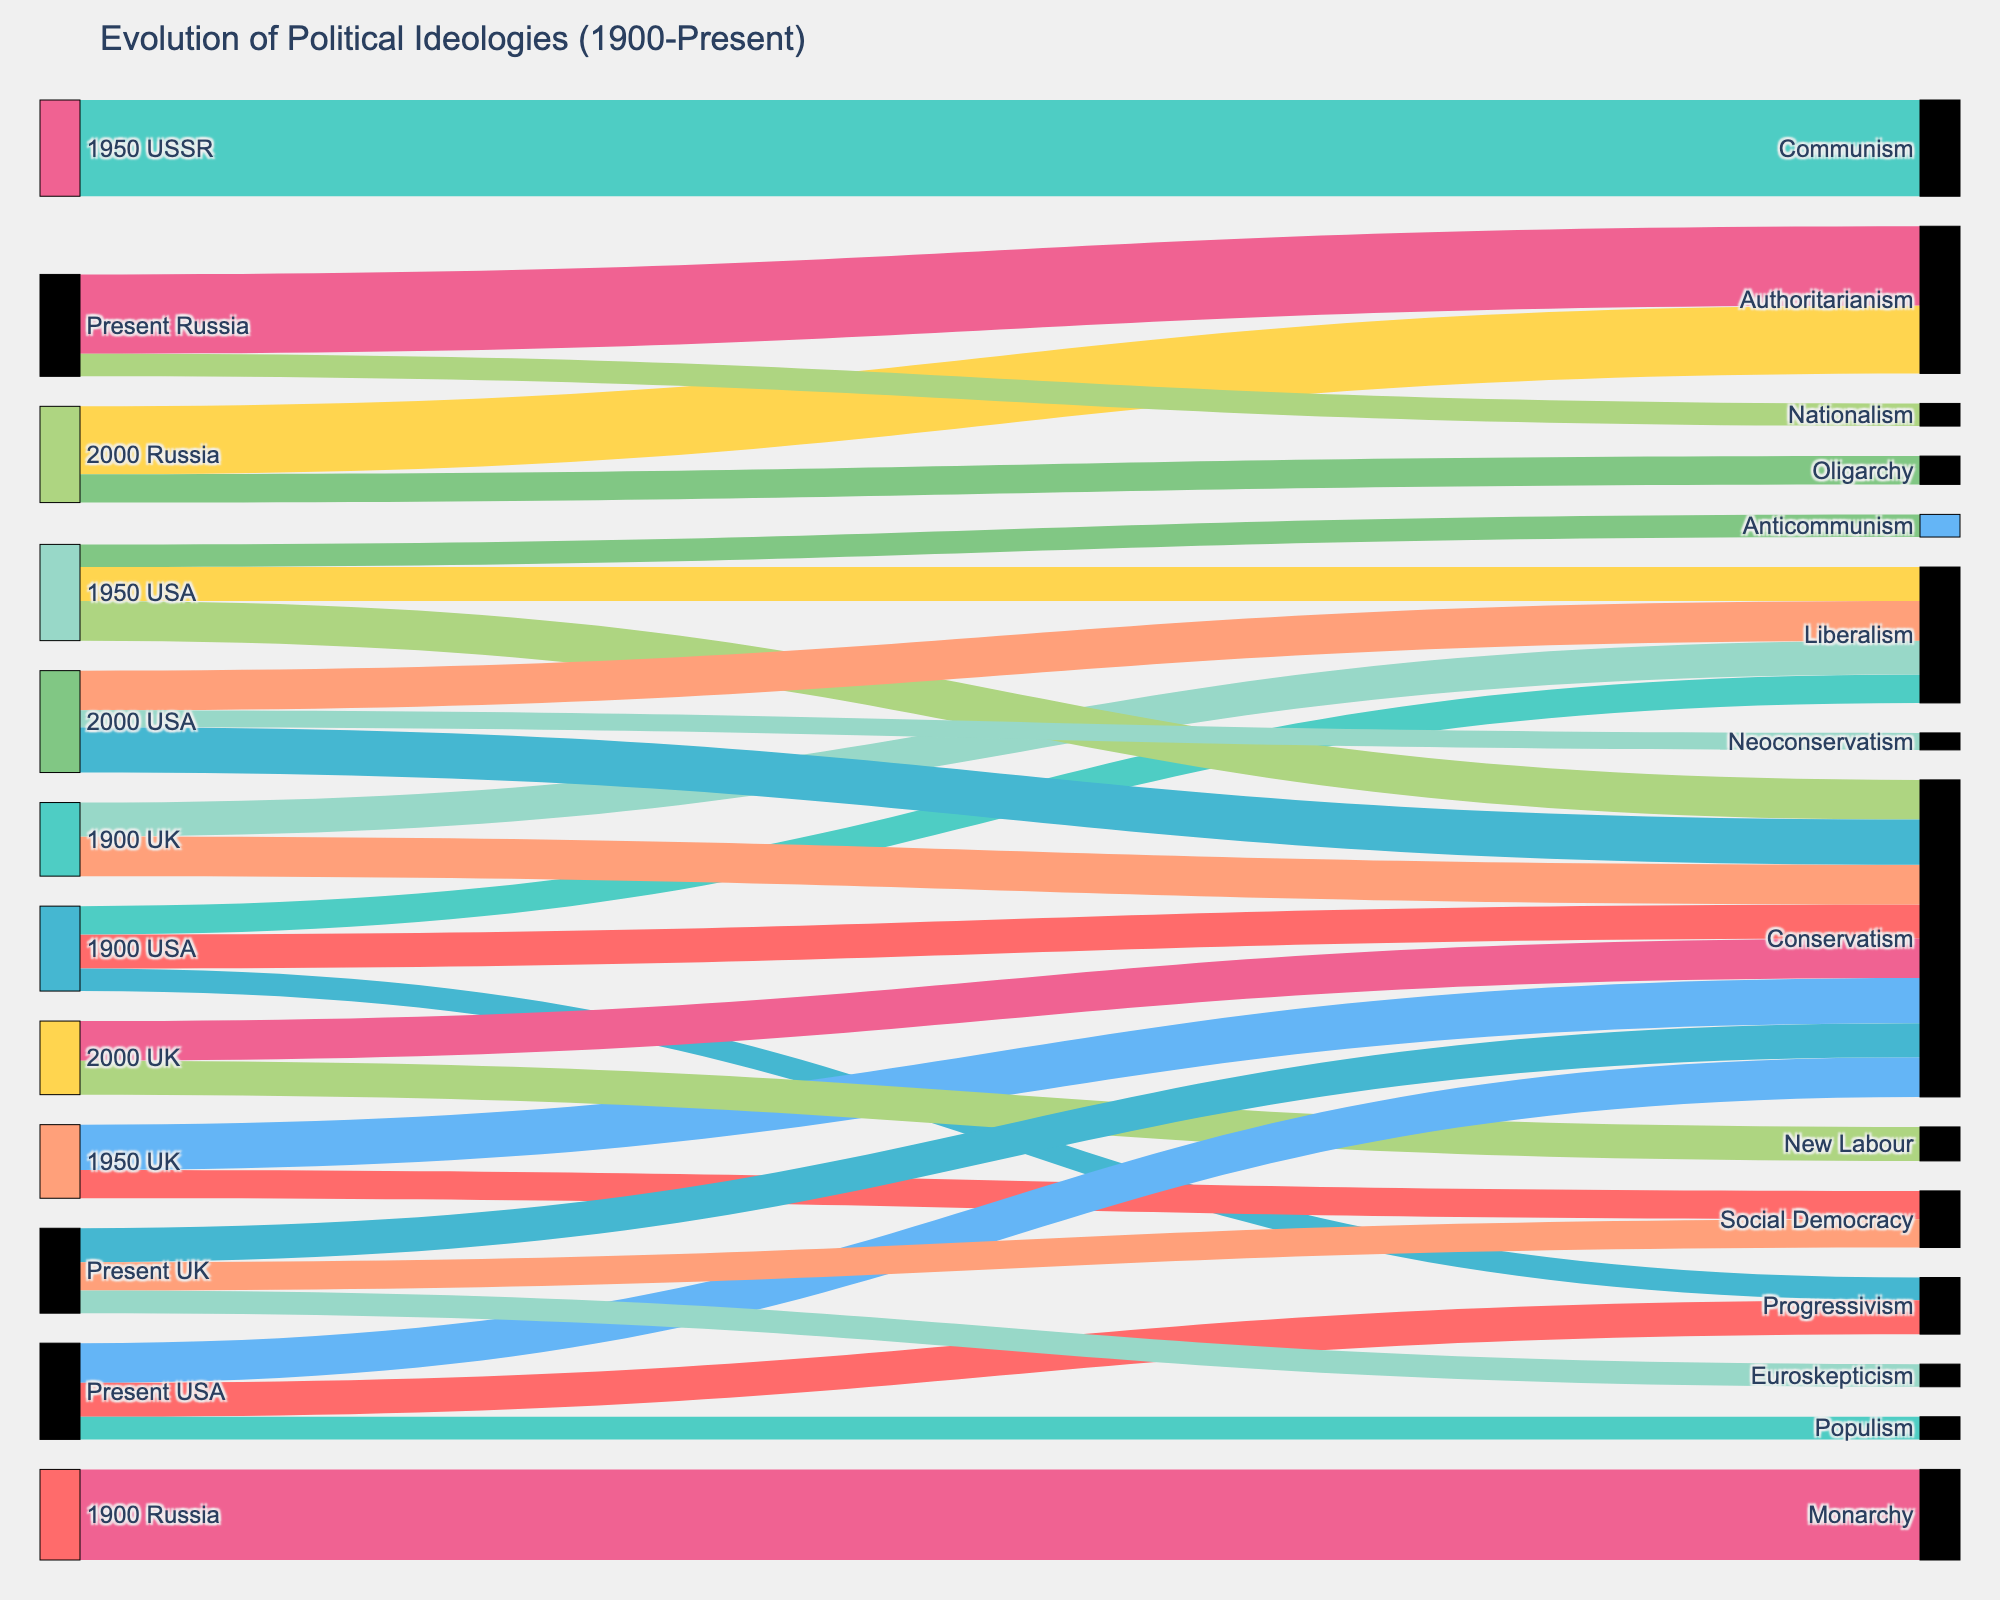Which political ideology in the USA had the highest value in 2000? To find the political ideology with the highest value in the USA in 2000, look at the targets connected to "2000 USA" and find the highest value among them. The values are 40 (Conservatism), 35 (Liberalism), and 15 (Neoconservatism).
Answer: Conservatism How did the value of Conservatism in the UK change from 1900 to the present? To determine this, compare the value of Conservatism in the UK in 1900, 1950, 2000, and Present. The values are 35 (1900), 40 (1950), 35 (2000), and 30 (Present). The value increased from 1900 to 1950, then returned to 35 in 2000, and dropped to 30 in the present.
Answer: Decreased from 35 to 30 Which country showed the most drastic change in political ideology from 1950 to the present? Compare changes in the values of political ideologies in the USA, UK, and Russia from 1950 to the present. Russia's Communism (1950) changed to Authoritarianism and Nationalism in the present. The shifts are marked compared to changes in the USA and UK.
Answer: Russia What is the total value of political ideologies in Russia in 2000? Add the values of all political ideologies in Russia in 2000. The values are 60 (Authoritarianism) and 25 (Oligarchy). Therefore, the total value is 60 + 25.
Answer: 85 Which political ideology decreased the most in the USA from 1950 to the present? Compare the values of political ideologies in the USA in 1950 and Present to determine the largest decrease. Anticommunism in 1950 had a value of 20, and it is absent in the present; thus, its value decreased by 20.
Answer: Anticommunism What is the sum of the values of Social Democracy in the UK across all years? Add the values of Social Democracy in the UK for 1950 (25) and Present (25). This is because Social Democracy appears only in these two time periods.
Answer: 50 How did the representation of Progressivism change in the USA from 1900 to the present? Compare the values of Progressivism in the USA in 1900 (20) and the present (30). Progressivism increased from 20 in 1900 to 30 in the present.
Answer: Increased from 20 to 30 Which political ideology appeared in the UK in the present that was not there in previous periods? Identify any political ideologies in the UK in the present that were not present in 1900, 1950, or 2000. Euroskepticism (20) appears only in the present.
Answer: Euroskepticism How has the value of Conservatism in the USA changed from 1950 to Present? Compare the values of Conservatism in the USA in 1950 (35) and the Present (35), which shows that the value of Conservatism remained the same between these periods.
Answer: Remained the same at 35 